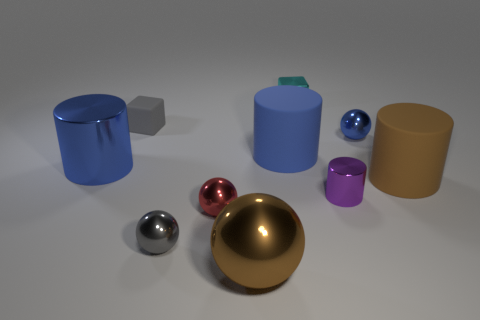Can you describe the arrangement of objects in terms of their sizes? Certainly! The objects are arranged in a somewhat scattered formation with varying sizes. On the left, there is a large blue cylinder and towards the right, a large gold sphere dominates in size. The middle ground features medium-sized objects, including a smaller cylinder and a cube, while the very small objects, likely the tiny rubber block and spheres, are in the foreground. 